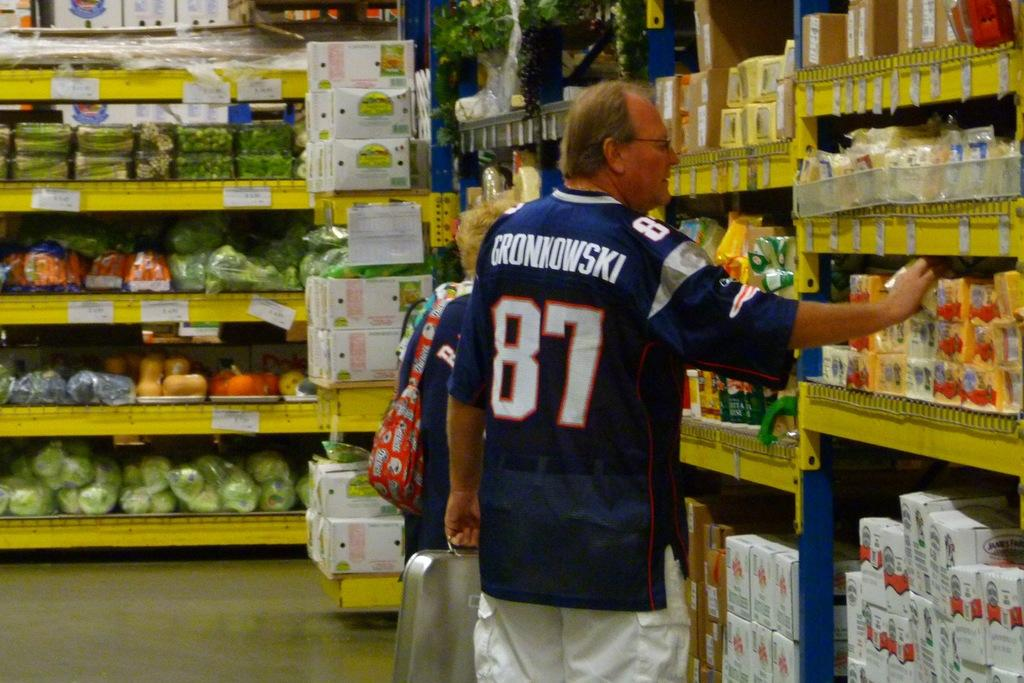<image>
Write a terse but informative summary of the picture. The player Gronkowski is looking for ingredients in a grocery store. 